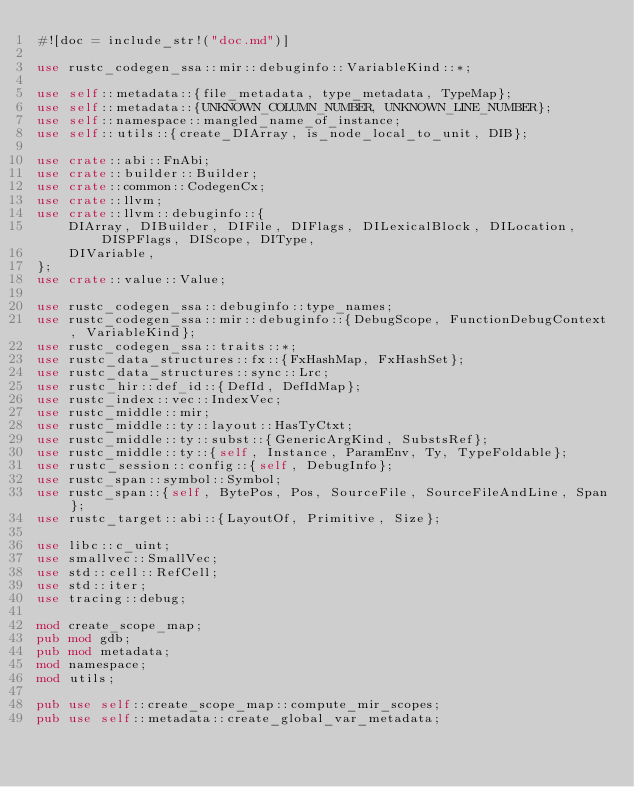Convert code to text. <code><loc_0><loc_0><loc_500><loc_500><_Rust_>#![doc = include_str!("doc.md")]

use rustc_codegen_ssa::mir::debuginfo::VariableKind::*;

use self::metadata::{file_metadata, type_metadata, TypeMap};
use self::metadata::{UNKNOWN_COLUMN_NUMBER, UNKNOWN_LINE_NUMBER};
use self::namespace::mangled_name_of_instance;
use self::utils::{create_DIArray, is_node_local_to_unit, DIB};

use crate::abi::FnAbi;
use crate::builder::Builder;
use crate::common::CodegenCx;
use crate::llvm;
use crate::llvm::debuginfo::{
    DIArray, DIBuilder, DIFile, DIFlags, DILexicalBlock, DILocation, DISPFlags, DIScope, DIType,
    DIVariable,
};
use crate::value::Value;

use rustc_codegen_ssa::debuginfo::type_names;
use rustc_codegen_ssa::mir::debuginfo::{DebugScope, FunctionDebugContext, VariableKind};
use rustc_codegen_ssa::traits::*;
use rustc_data_structures::fx::{FxHashMap, FxHashSet};
use rustc_data_structures::sync::Lrc;
use rustc_hir::def_id::{DefId, DefIdMap};
use rustc_index::vec::IndexVec;
use rustc_middle::mir;
use rustc_middle::ty::layout::HasTyCtxt;
use rustc_middle::ty::subst::{GenericArgKind, SubstsRef};
use rustc_middle::ty::{self, Instance, ParamEnv, Ty, TypeFoldable};
use rustc_session::config::{self, DebugInfo};
use rustc_span::symbol::Symbol;
use rustc_span::{self, BytePos, Pos, SourceFile, SourceFileAndLine, Span};
use rustc_target::abi::{LayoutOf, Primitive, Size};

use libc::c_uint;
use smallvec::SmallVec;
use std::cell::RefCell;
use std::iter;
use tracing::debug;

mod create_scope_map;
pub mod gdb;
pub mod metadata;
mod namespace;
mod utils;

pub use self::create_scope_map::compute_mir_scopes;
pub use self::metadata::create_global_var_metadata;</code> 